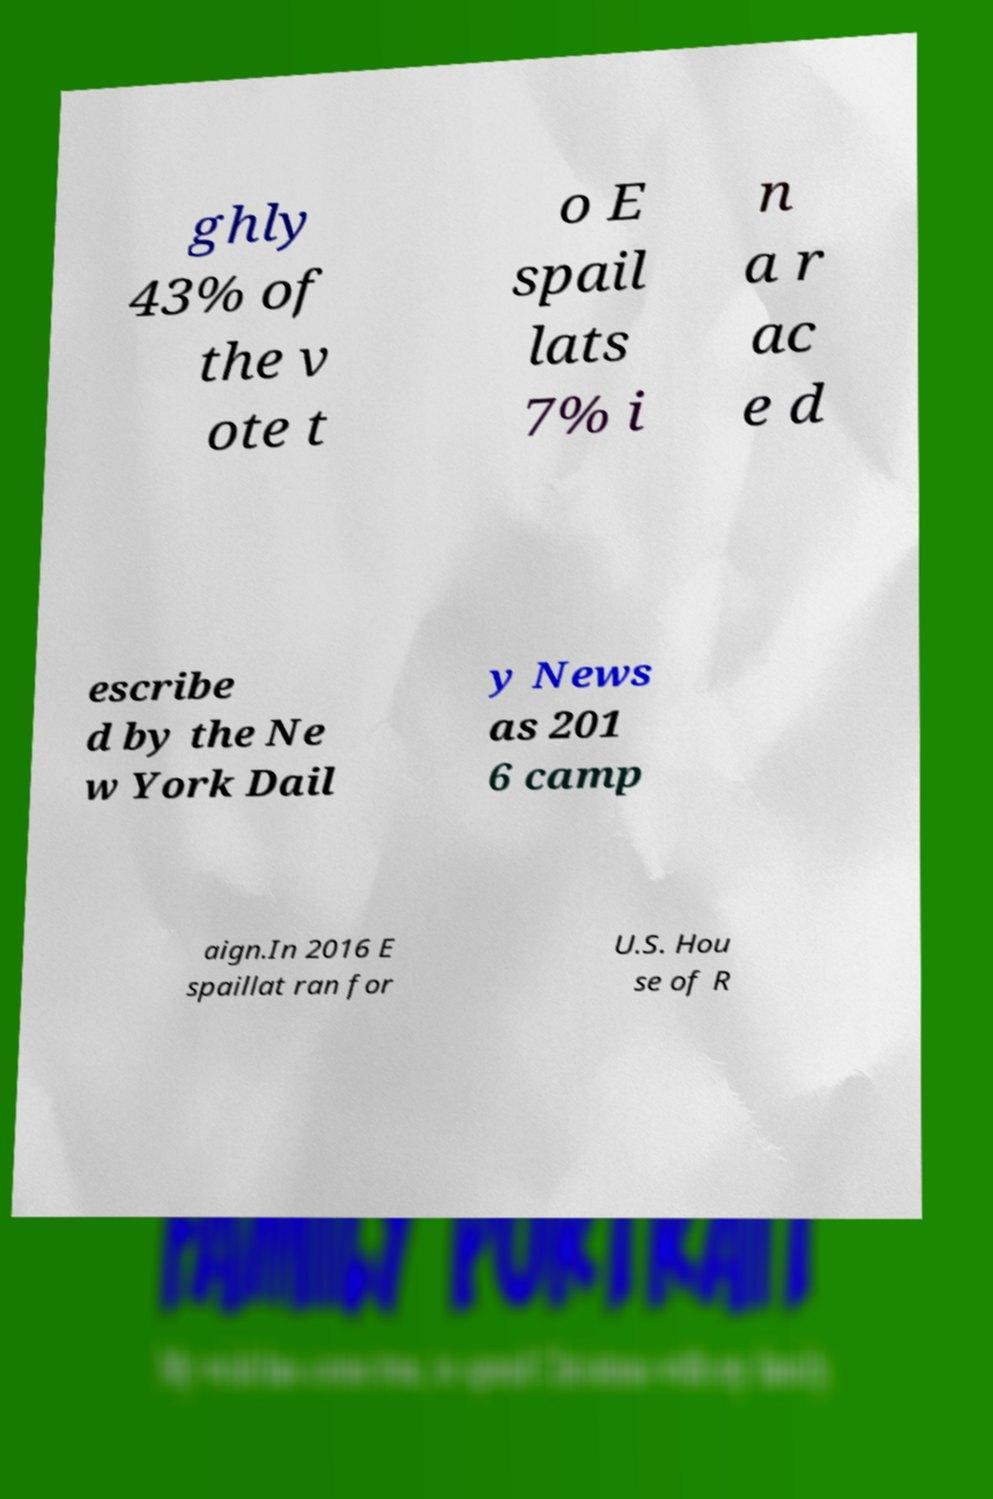Please identify and transcribe the text found in this image. ghly 43% of the v ote t o E spail lats 7% i n a r ac e d escribe d by the Ne w York Dail y News as 201 6 camp aign.In 2016 E spaillat ran for U.S. Hou se of R 